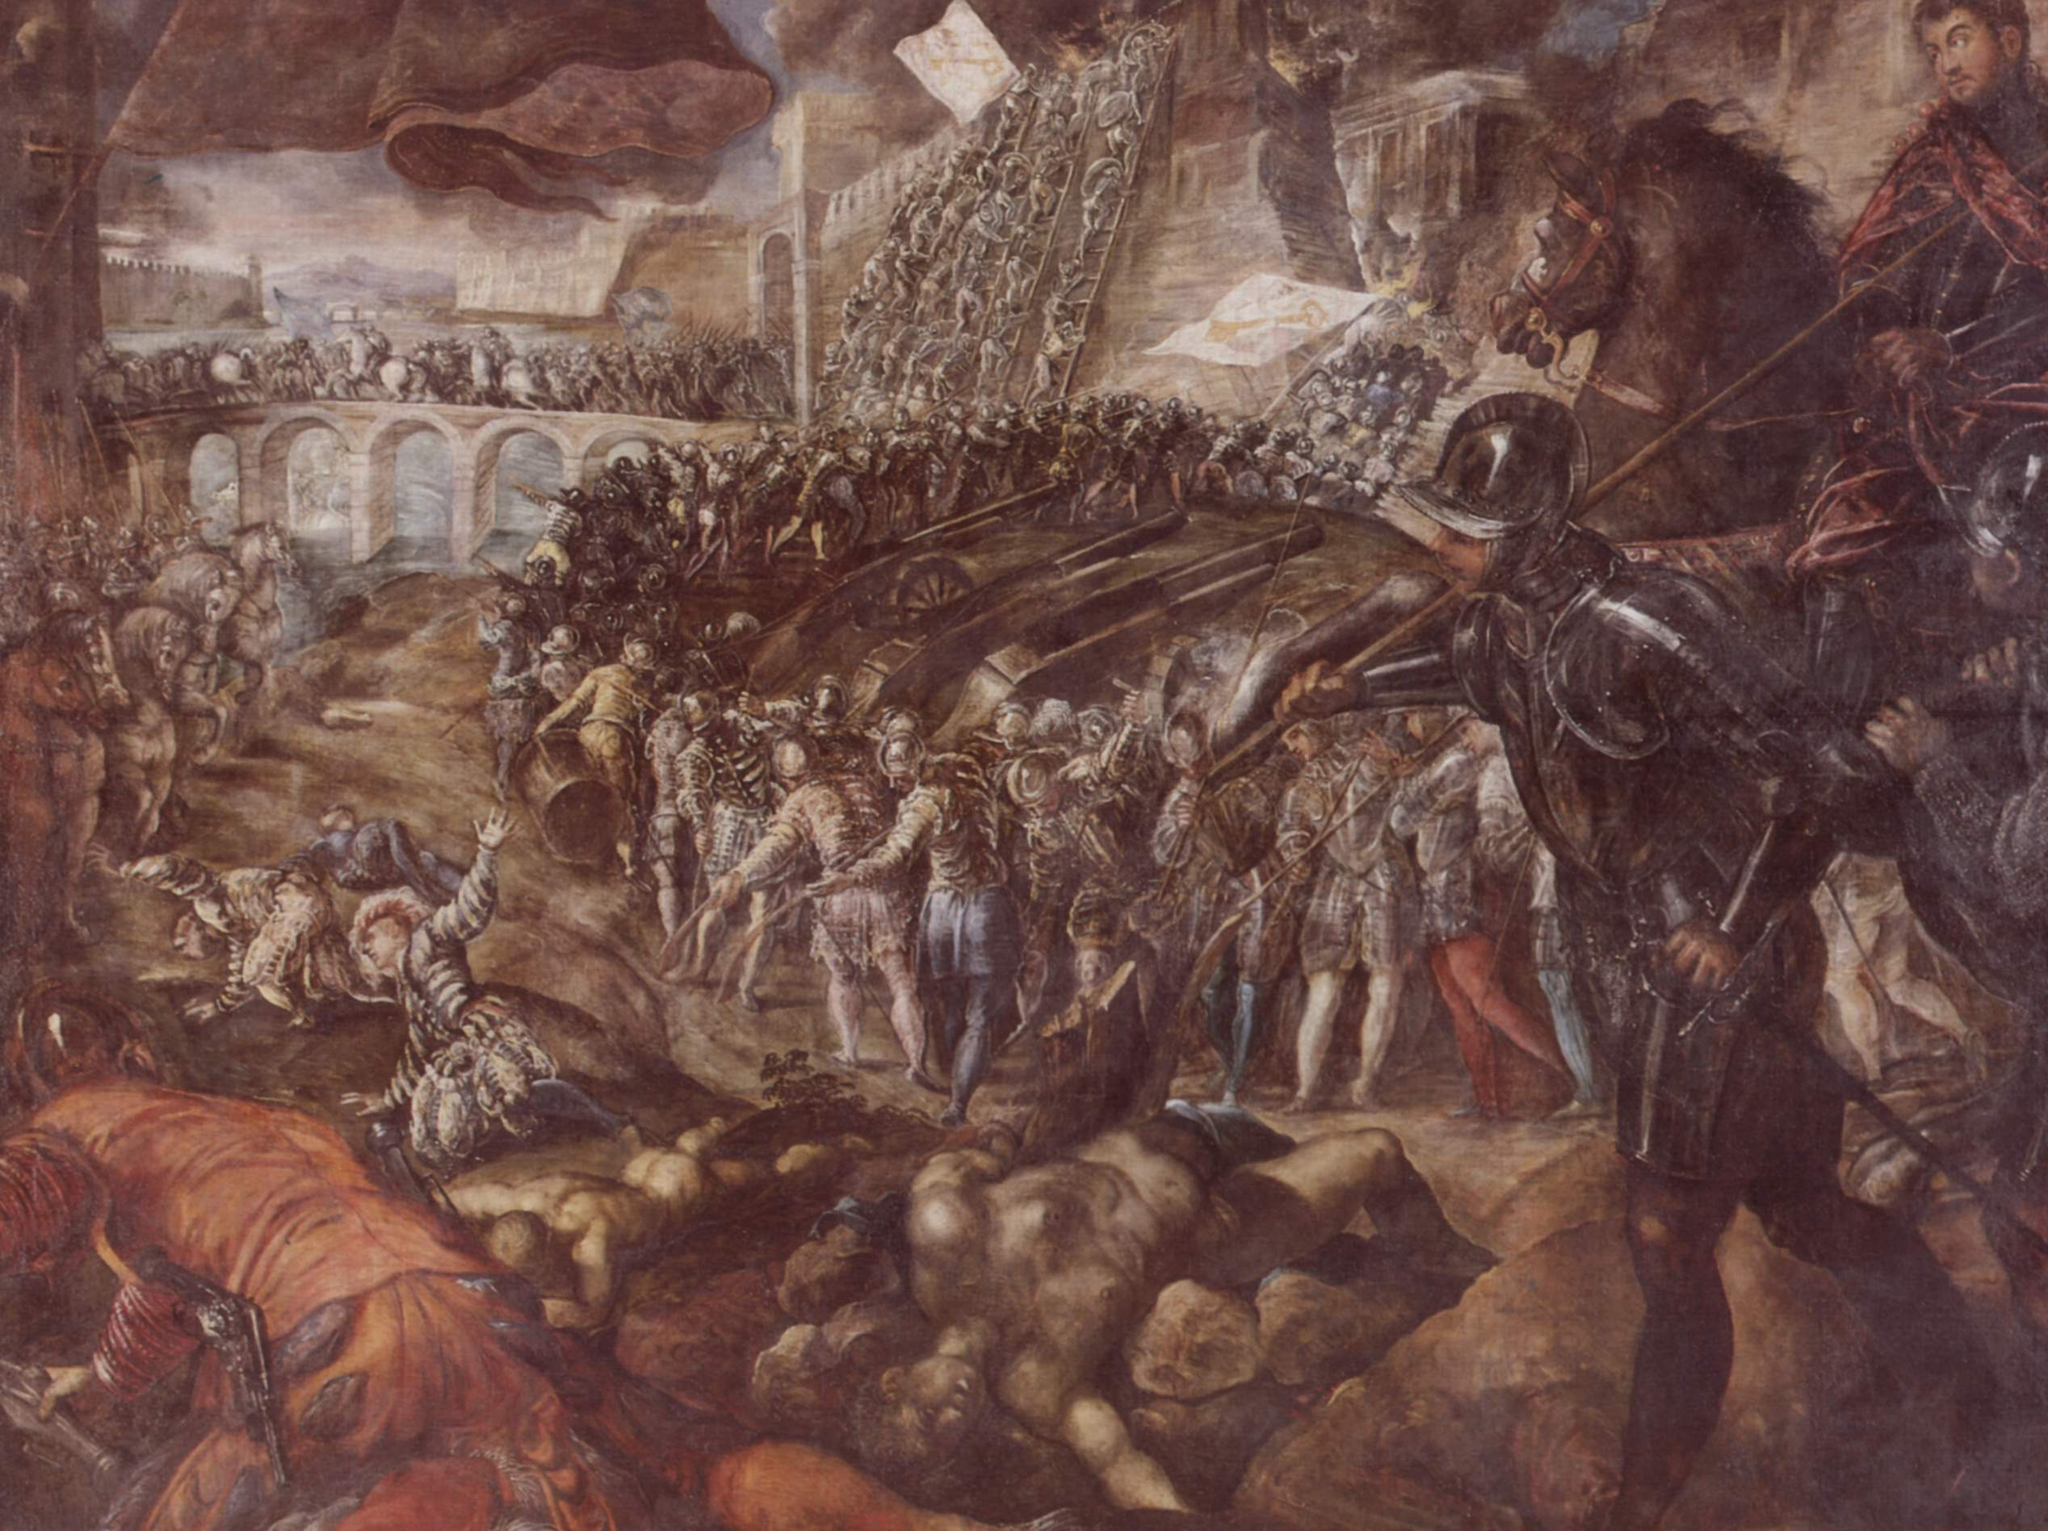What can you infer about the historical context of this battle scene? The image suggests a battle from the Renaissance period or late medieval era, given the style of armor and weaponry depicted. The soldiers are equipped with plate armor and wield weapons characteristic of this time, such as swords, halberds, and lances. The presence of fortifications and a stone bridge implies a strategic location, possibly a fortress or a city under siege. The detailed portrayal of the combat and the attire of the figures suggest a significant military engagement, potentially involving knights, indicating the importance of the conflict in the historical context. This scene could represent a critical battle, perhaps tied to territorial disputes or power struggles characteristic of European history during this period. 